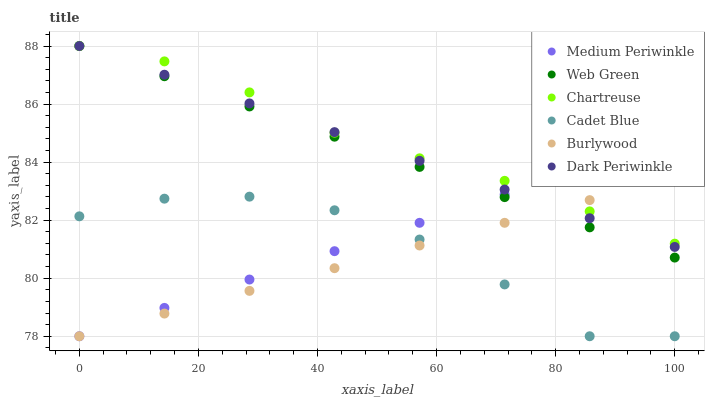Does Burlywood have the minimum area under the curve?
Answer yes or no. Yes. Does Chartreuse have the maximum area under the curve?
Answer yes or no. Yes. Does Medium Periwinkle have the minimum area under the curve?
Answer yes or no. No. Does Medium Periwinkle have the maximum area under the curve?
Answer yes or no. No. Is Web Green the smoothest?
Answer yes or no. Yes. Is Cadet Blue the roughest?
Answer yes or no. Yes. Is Burlywood the smoothest?
Answer yes or no. No. Is Burlywood the roughest?
Answer yes or no. No. Does Cadet Blue have the lowest value?
Answer yes or no. Yes. Does Web Green have the lowest value?
Answer yes or no. No. Does Dark Periwinkle have the highest value?
Answer yes or no. Yes. Does Burlywood have the highest value?
Answer yes or no. No. Is Cadet Blue less than Chartreuse?
Answer yes or no. Yes. Is Web Green greater than Cadet Blue?
Answer yes or no. Yes. Does Web Green intersect Dark Periwinkle?
Answer yes or no. Yes. Is Web Green less than Dark Periwinkle?
Answer yes or no. No. Is Web Green greater than Dark Periwinkle?
Answer yes or no. No. Does Cadet Blue intersect Chartreuse?
Answer yes or no. No. 